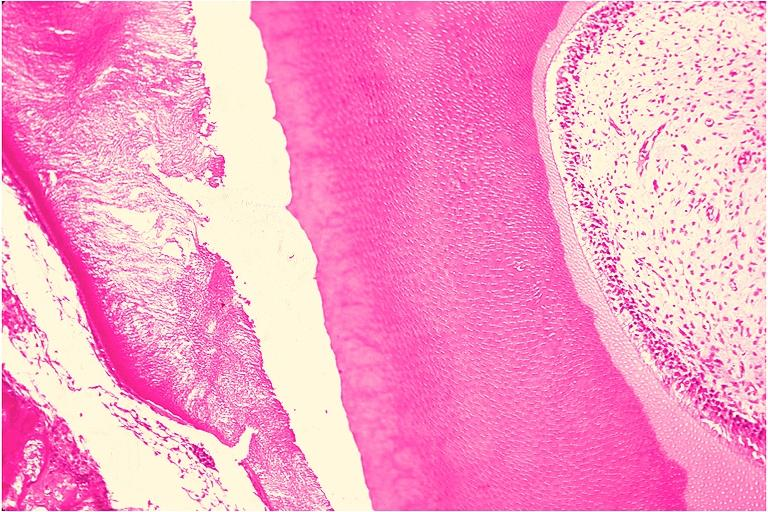does this image show odontoma?
Answer the question using a single word or phrase. Yes 